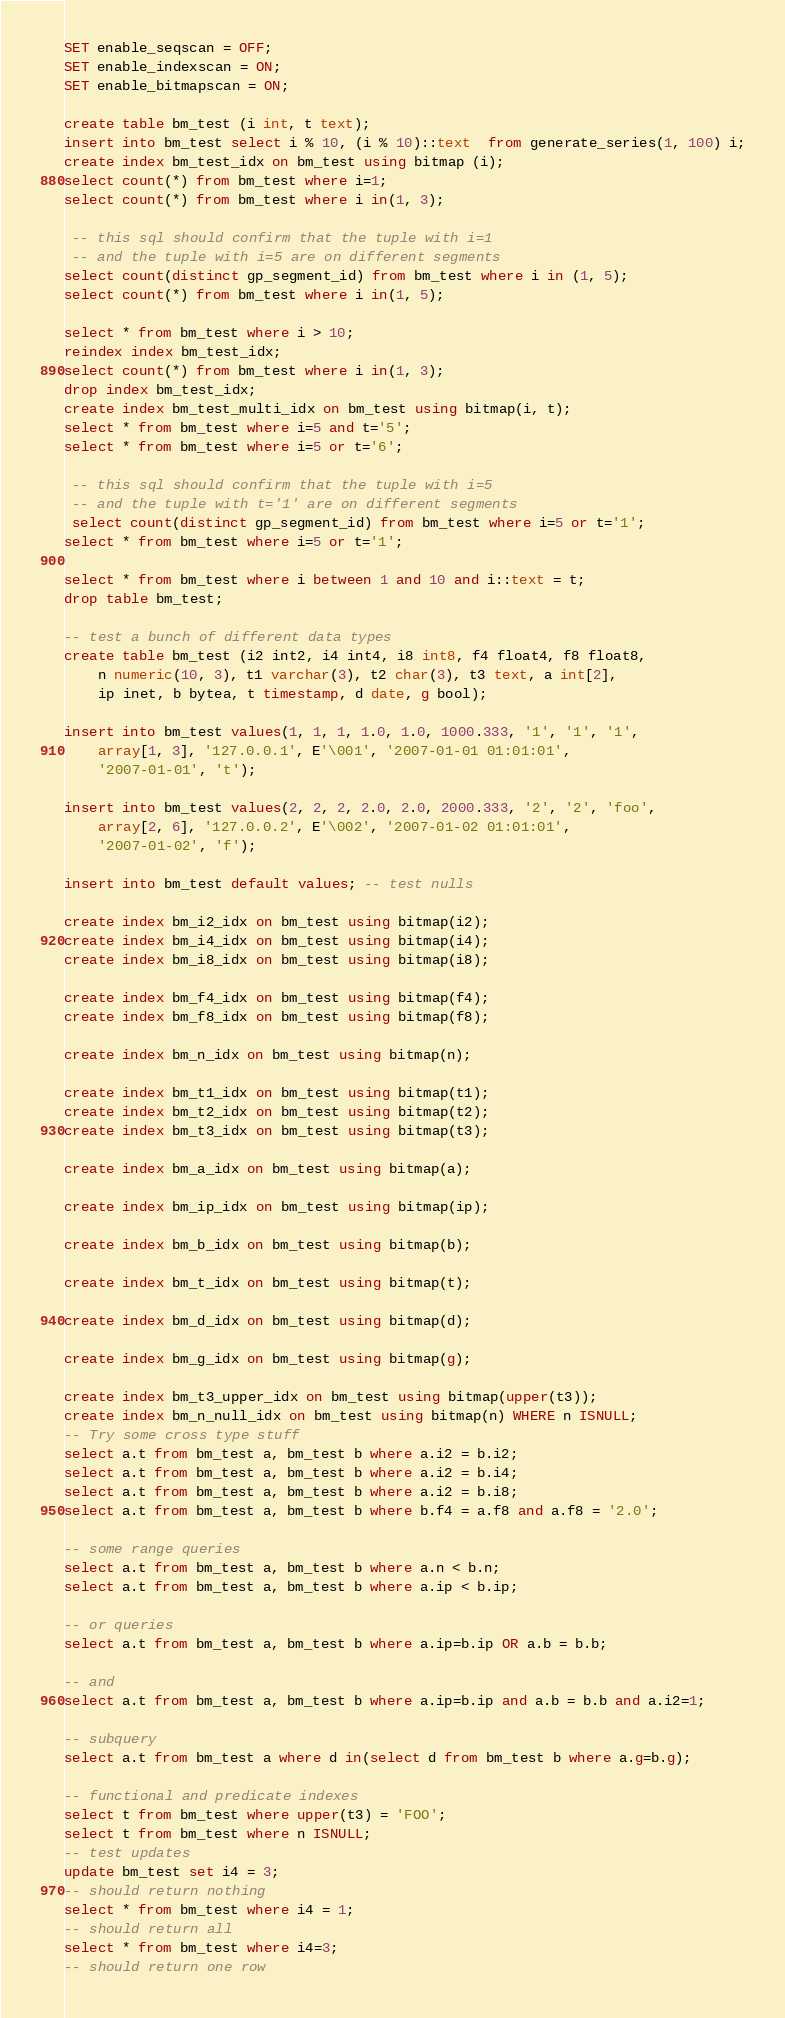<code> <loc_0><loc_0><loc_500><loc_500><_SQL_>SET enable_seqscan = OFF;
SET enable_indexscan = ON;
SET enable_bitmapscan = ON;

create table bm_test (i int, t text);
insert into bm_test select i % 10, (i % 10)::text  from generate_series(1, 100) i;
create index bm_test_idx on bm_test using bitmap (i);
select count(*) from bm_test where i=1;
select count(*) from bm_test where i in(1, 3);

 -- this sql should confirm that the tuple with i=1
 -- and the tuple with i=5 are on different segments
select count(distinct gp_segment_id) from bm_test where i in (1, 5);
select count(*) from bm_test where i in(1, 5);

select * from bm_test where i > 10;
reindex index bm_test_idx;
select count(*) from bm_test where i in(1, 3);
drop index bm_test_idx;
create index bm_test_multi_idx on bm_test using bitmap(i, t);
select * from bm_test where i=5 and t='5';
select * from bm_test where i=5 or t='6';

 -- this sql should confirm that the tuple with i=5
 -- and the tuple with t='1' are on different segments
 select count(distinct gp_segment_id) from bm_test where i=5 or t='1';
select * from bm_test where i=5 or t='1';

select * from bm_test where i between 1 and 10 and i::text = t;
drop table bm_test;

-- test a bunch of different data types
create table bm_test (i2 int2, i4 int4, i8 int8, f4 float4, f8 float8,
	n numeric(10, 3), t1 varchar(3), t2 char(3), t3 text, a int[2],
	ip inet, b bytea, t timestamp, d date, g bool);

insert into bm_test values(1, 1, 1, 1.0, 1.0, 1000.333, '1', '1', '1',
    array[1, 3], '127.0.0.1', E'\001', '2007-01-01 01:01:01',
    '2007-01-01', 't');

insert into bm_test values(2, 2, 2, 2.0, 2.0, 2000.333, '2', '2', 'foo',
    array[2, 6], '127.0.0.2', E'\002', '2007-01-02 01:01:01',
    '2007-01-02', 'f');

insert into bm_test default values; -- test nulls

create index bm_i2_idx on bm_test using bitmap(i2);
create index bm_i4_idx on bm_test using bitmap(i4);
create index bm_i8_idx on bm_test using bitmap(i8);

create index bm_f4_idx on bm_test using bitmap(f4);
create index bm_f8_idx on bm_test using bitmap(f8);

create index bm_n_idx on bm_test using bitmap(n);

create index bm_t1_idx on bm_test using bitmap(t1);
create index bm_t2_idx on bm_test using bitmap(t2);
create index bm_t3_idx on bm_test using bitmap(t3);

create index bm_a_idx on bm_test using bitmap(a);

create index bm_ip_idx on bm_test using bitmap(ip);

create index bm_b_idx on bm_test using bitmap(b);

create index bm_t_idx on bm_test using bitmap(t);

create index bm_d_idx on bm_test using bitmap(d);

create index bm_g_idx on bm_test using bitmap(g);

create index bm_t3_upper_idx on bm_test using bitmap(upper(t3));
create index bm_n_null_idx on bm_test using bitmap(n) WHERE n ISNULL;
-- Try some cross type stuff
select a.t from bm_test a, bm_test b where a.i2 = b.i2;
select a.t from bm_test a, bm_test b where a.i2 = b.i4;
select a.t from bm_test a, bm_test b where a.i2 = b.i8;
select a.t from bm_test a, bm_test b where b.f4 = a.f8 and a.f8 = '2.0';

-- some range queries
select a.t from bm_test a, bm_test b where a.n < b.n;
select a.t from bm_test a, bm_test b where a.ip < b.ip;

-- or queries
select a.t from bm_test a, bm_test b where a.ip=b.ip OR a.b = b.b;

-- and
select a.t from bm_test a, bm_test b where a.ip=b.ip and a.b = b.b and a.i2=1;

-- subquery
select a.t from bm_test a where d in(select d from bm_test b where a.g=b.g);

-- functional and predicate indexes
select t from bm_test where upper(t3) = 'FOO';
select t from bm_test where n ISNULL;
-- test updates
update bm_test set i4 = 3;
-- should return nothing
select * from bm_test where i4 = 1;
-- should return all
select * from bm_test where i4=3;
-- should return one row</code> 